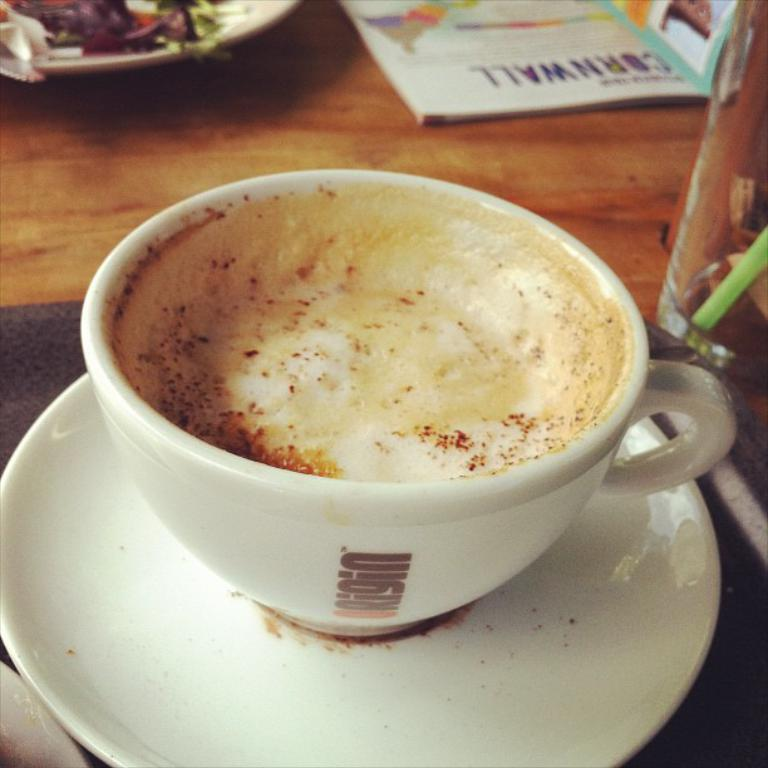What piece of furniture is present in the image? There is a table in the image. What is placed on the table? There is a plate, a book, a bottle, a coffee cup, and a saucer on the table. Can you describe the items on the table in more detail? The plate is likely for holding food, the book might be for reading, the bottle could contain a beverage, the coffee cup is for drinking coffee, and the saucer is typically used to hold the coffee cup. What type of music is being played by the army in the image? There is no army or music present in the image; it features a table with various items on it. 